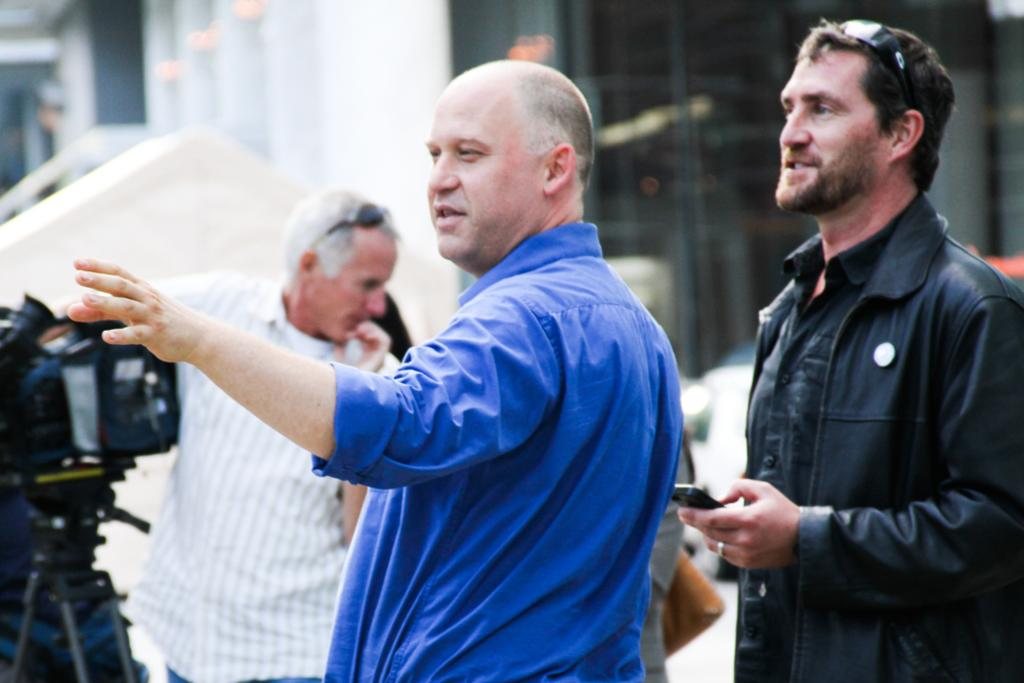What is happening in the image? There are people standing in the image. Can you describe what one of the people is holding? A man is holding a mobile in the image. What equipment is visible in the image? There is a camera with a tripod in the image. How would you describe the background of the image? The background of the image is blurry. How many women are standing near the bushes in the image? There are no women or bushes present in the image. What type of chicken can be seen in the image? There is no chicken present in the image. 